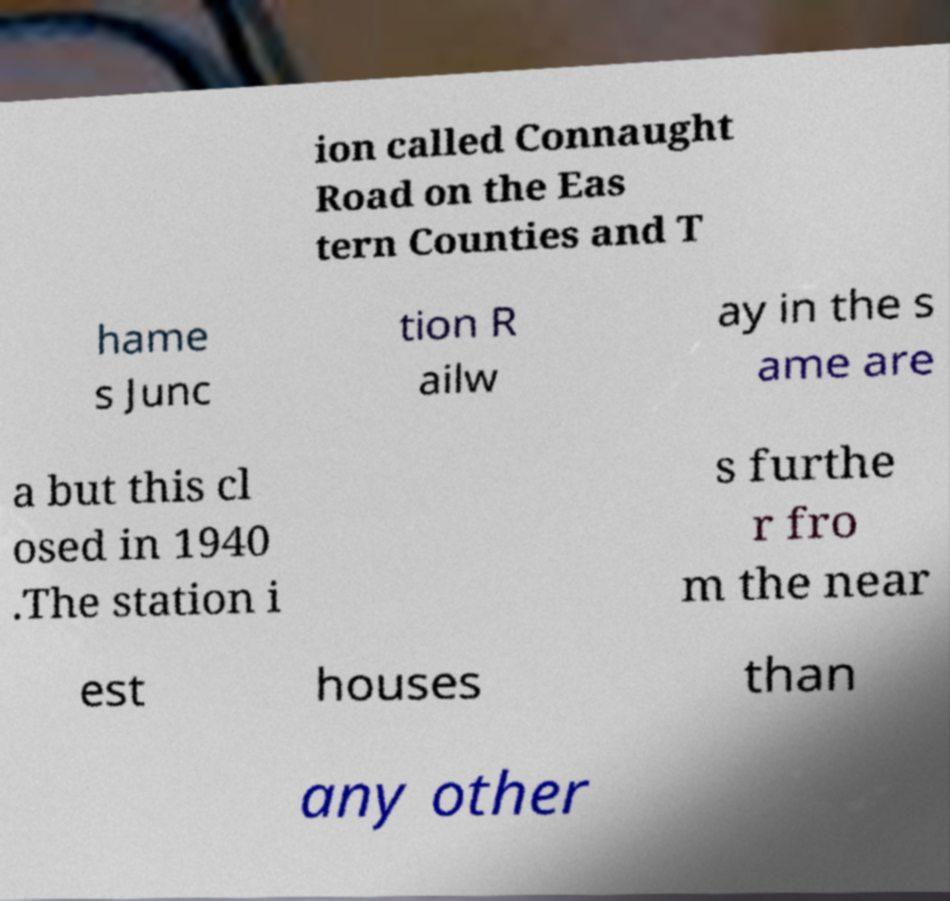Can you read and provide the text displayed in the image?This photo seems to have some interesting text. Can you extract and type it out for me? ion called Connaught Road on the Eas tern Counties and T hame s Junc tion R ailw ay in the s ame are a but this cl osed in 1940 .The station i s furthe r fro m the near est houses than any other 